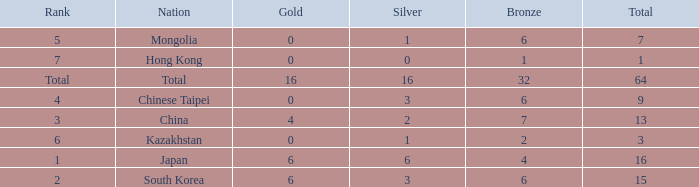Parse the table in full. {'header': ['Rank', 'Nation', 'Gold', 'Silver', 'Bronze', 'Total'], 'rows': [['5', 'Mongolia', '0', '1', '6', '7'], ['7', 'Hong Kong', '0', '0', '1', '1'], ['Total', 'Total', '16', '16', '32', '64'], ['4', 'Chinese Taipei', '0', '3', '6', '9'], ['3', 'China', '4', '2', '7', '13'], ['6', 'Kazakhstan', '0', '1', '2', '3'], ['1', 'Japan', '6', '6', '4', '16'], ['2', 'South Korea', '6', '3', '6', '15']]} Which Silver has a Nation of china, and a Bronze smaller than 7? None. 